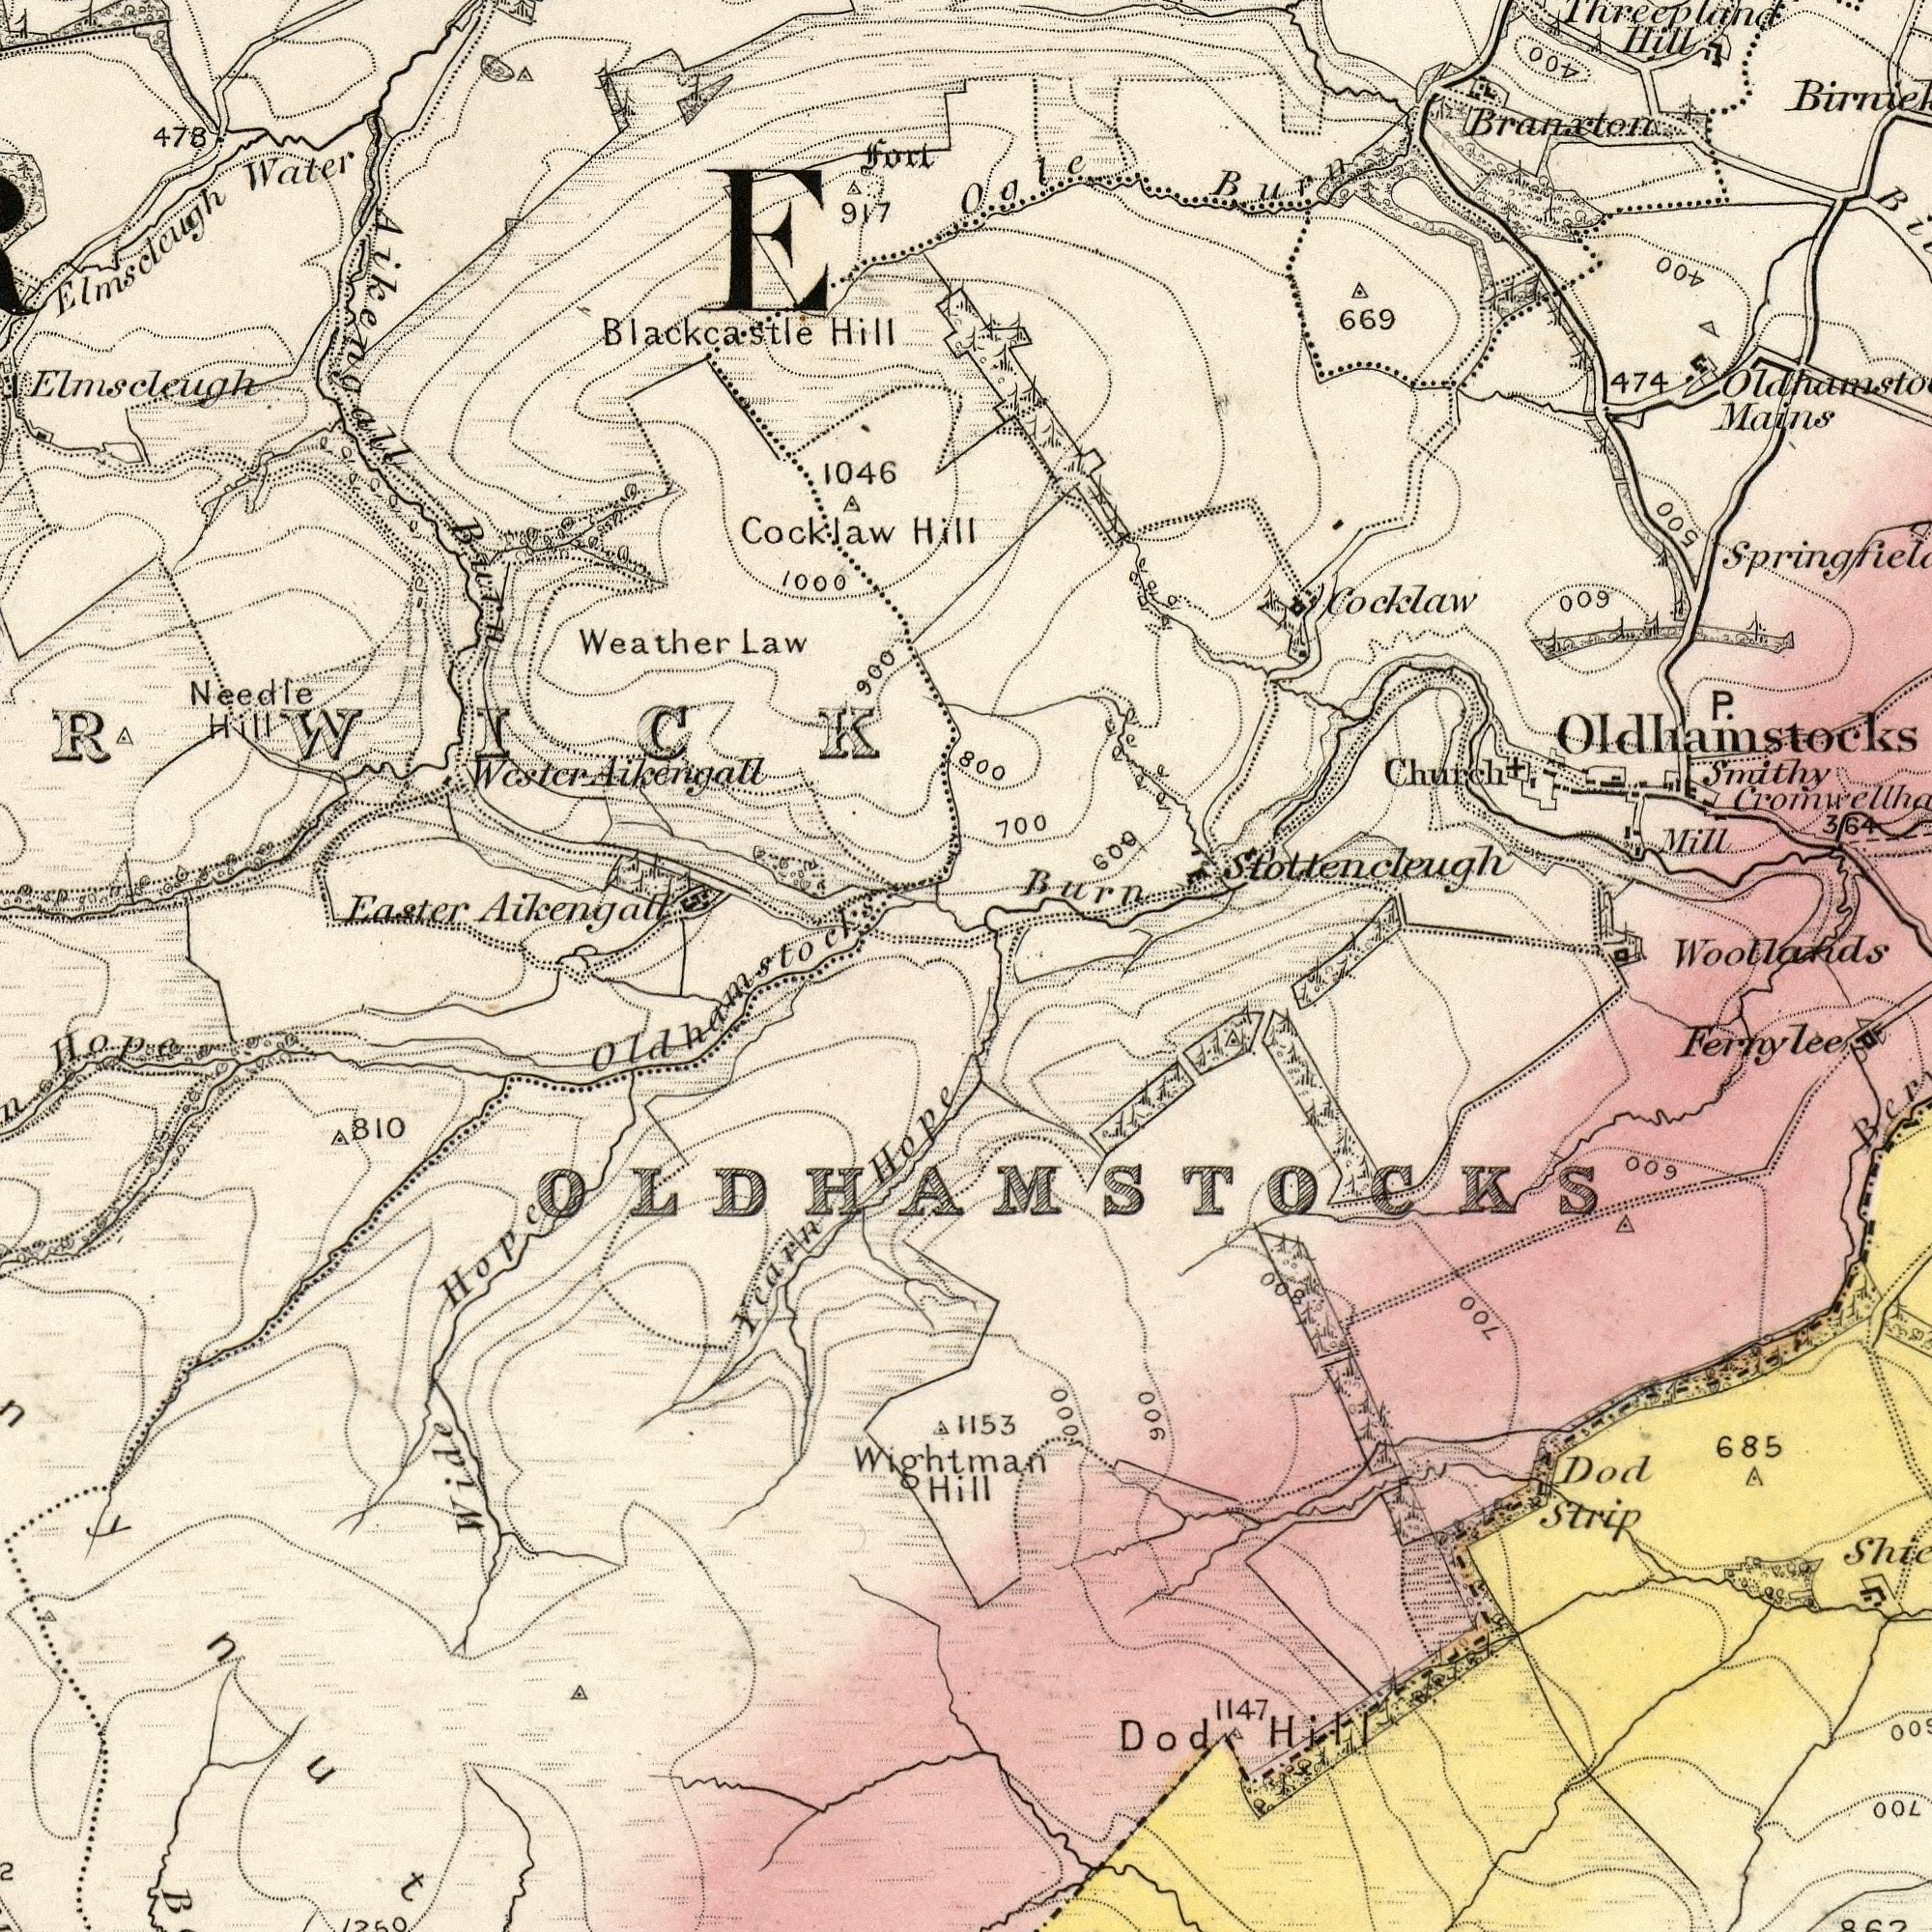What text is visible in the upper-left corner? Weather Aikengall 1046 Water Needle 900 Hill 917 Law Elmscleugh 478 fort 1000 Aikengall Hill Blackcastle Hill Cocklaw Burn Elmscleugh Wester Aikengall What text appears in the top-right area of the image? Branxto Burn Cocklaw Mains 669 Smithy 700 600 Hill 474 Mill Church P. Ogle Burn 364 Threepland 800 Oldhamstocks 400 400 Stottencleugh 600 500 What text is shown in the bottom-left quadrant? Easter Yearn 810 Hope Wightman Wide Hope Hill Old hamstocks Hope What text is visible in the lower-right corner? Woollands Strip Dod 685 1153 1147 Dod Fernylee Hill 700 800 900 1000 OLDHAMSTOCKS 600 700 600 